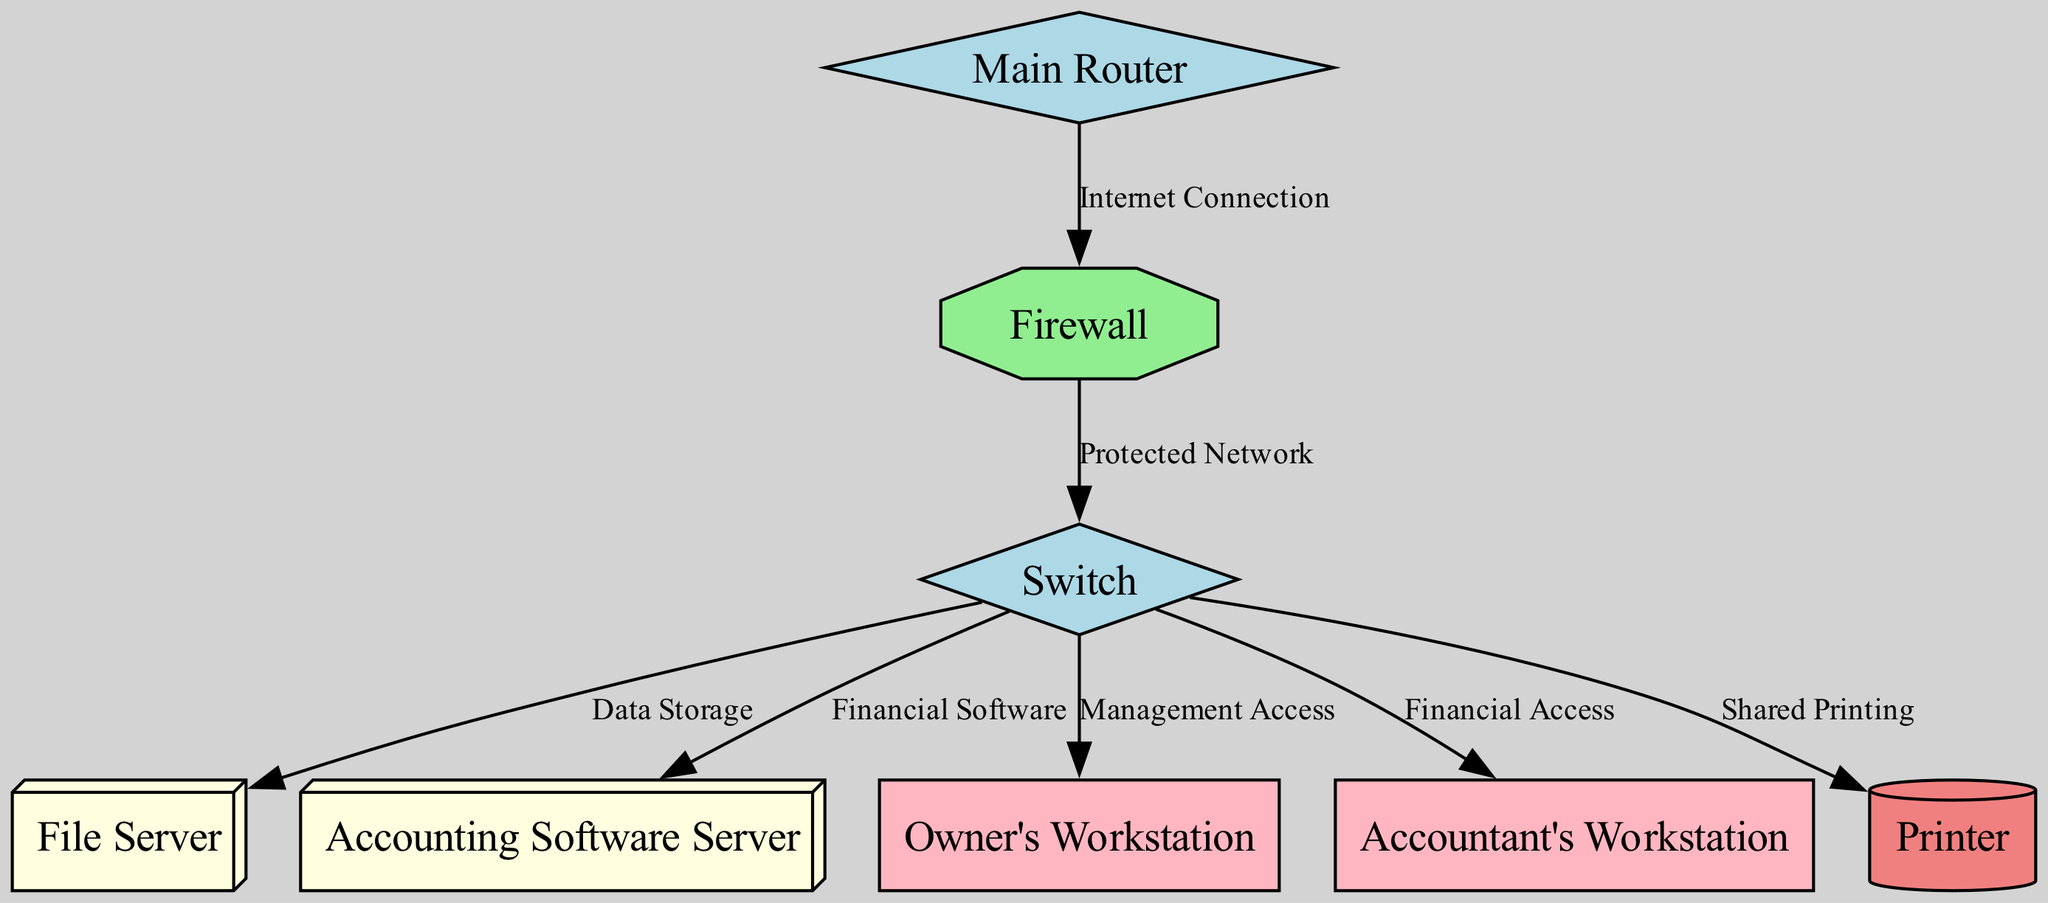What is the name of the main security device in the network? The main security device in the network is labeled as "Firewall" and is specifically identified by the node type "security."
Answer: Firewall How many servers are represented in the diagram? The diagram shows two servers: the "File Server" and the "Accounting Software Server." Therefore, counting these nodes gives a total of two servers.
Answer: 2 Which workstation has access to financial software? The workstation that has access to financial software is named "Accountant's Workstation," which is connected to the "Accounting Software Server" through the switch.
Answer: Accountant's Workstation What type of connection does the Main Router have to the Firewall? The connection between the Main Router and the Firewall is labeled "Internet Connection." This indicates that the traffic from the internet flows into the firewall through this connection.
Answer: Internet Connection Which device connects all other devices on the protected network? The device that connects all other devices on the protected network is termed the "Switch." It serves as a central point for connections in the protected network, connecting to multiple nodes like servers and workstations.
Answer: Switch What is the purpose of the edge labeled “Shared Printing”? The edge labeled “Shared Printing” connects the Switch to the Printer, indicating that the purpose of this connection is to allow multiple workstations in the network to access the printer for shared printing tasks.
Answer: Shared Printing What is the relationship between the File Server and the Switch? The File Server connects to the Switch via an edge labeled "Data Storage," signifying that data from the File Server is accessible through the Switch to other connected devices in the network.
Answer: Data Storage Which node type does the Owner's Workstation belong to? The "Owner's Workstation" belongs to the type labeled as "workstation," which is indicated clearly in its node definition within the diagram.
Answer: workstation How many connections does the Switch have in total? The Switch connects to six devices: the File Server, the Accounting Software Server, the Owner's Workstation, the Accountant's Workstation, the Printer, and the Firewall, resulting in a total of six connections.
Answer: 6 